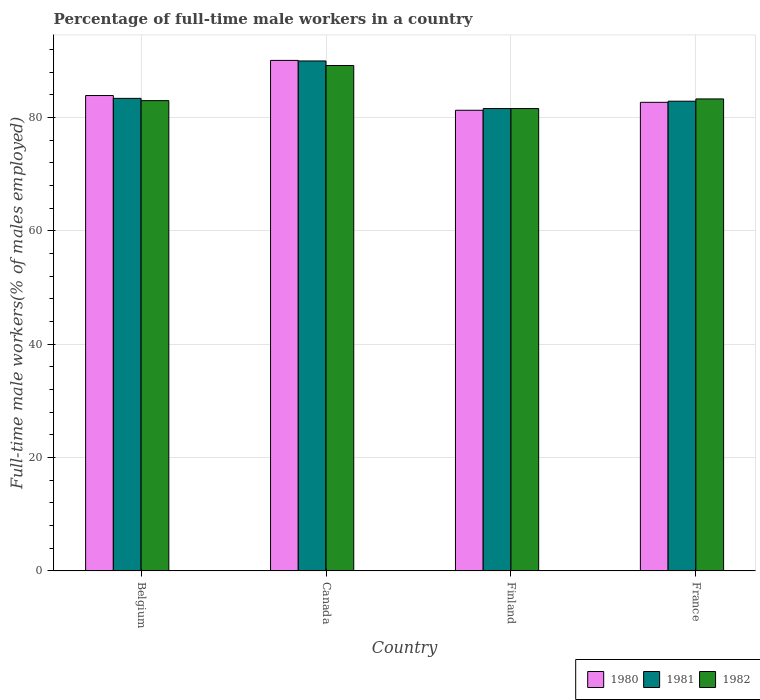How many different coloured bars are there?
Your answer should be very brief. 3. Are the number of bars per tick equal to the number of legend labels?
Make the answer very short. Yes. How many bars are there on the 4th tick from the left?
Give a very brief answer. 3. How many bars are there on the 1st tick from the right?
Your answer should be very brief. 3. What is the percentage of full-time male workers in 1980 in Belgium?
Your response must be concise. 83.9. Across all countries, what is the maximum percentage of full-time male workers in 1980?
Keep it short and to the point. 90.1. Across all countries, what is the minimum percentage of full-time male workers in 1982?
Your answer should be compact. 81.6. In which country was the percentage of full-time male workers in 1980 maximum?
Provide a short and direct response. Canada. In which country was the percentage of full-time male workers in 1981 minimum?
Your answer should be very brief. Finland. What is the total percentage of full-time male workers in 1982 in the graph?
Provide a short and direct response. 337.1. What is the difference between the percentage of full-time male workers in 1980 in Belgium and that in Finland?
Your answer should be very brief. 2.6. What is the difference between the percentage of full-time male workers in 1982 in Canada and the percentage of full-time male workers in 1981 in Finland?
Offer a very short reply. 7.6. What is the average percentage of full-time male workers in 1980 per country?
Keep it short and to the point. 84.5. What is the difference between the percentage of full-time male workers of/in 1982 and percentage of full-time male workers of/in 1980 in Finland?
Give a very brief answer. 0.3. What is the ratio of the percentage of full-time male workers in 1982 in Canada to that in Finland?
Provide a short and direct response. 1.09. Is the percentage of full-time male workers in 1980 in Belgium less than that in France?
Keep it short and to the point. No. What is the difference between the highest and the second highest percentage of full-time male workers in 1982?
Provide a short and direct response. 6.2. What is the difference between the highest and the lowest percentage of full-time male workers in 1982?
Provide a short and direct response. 7.6. In how many countries, is the percentage of full-time male workers in 1981 greater than the average percentage of full-time male workers in 1981 taken over all countries?
Provide a short and direct response. 1. What does the 2nd bar from the right in France represents?
Provide a short and direct response. 1981. Is it the case that in every country, the sum of the percentage of full-time male workers in 1981 and percentage of full-time male workers in 1982 is greater than the percentage of full-time male workers in 1980?
Your answer should be very brief. Yes. How many bars are there?
Provide a succinct answer. 12. Are all the bars in the graph horizontal?
Keep it short and to the point. No. How many countries are there in the graph?
Provide a succinct answer. 4. Are the values on the major ticks of Y-axis written in scientific E-notation?
Your answer should be very brief. No. Does the graph contain any zero values?
Your response must be concise. No. Does the graph contain grids?
Make the answer very short. Yes. Where does the legend appear in the graph?
Your answer should be very brief. Bottom right. How many legend labels are there?
Ensure brevity in your answer.  3. What is the title of the graph?
Keep it short and to the point. Percentage of full-time male workers in a country. What is the label or title of the Y-axis?
Your answer should be very brief. Full-time male workers(% of males employed). What is the Full-time male workers(% of males employed) of 1980 in Belgium?
Your response must be concise. 83.9. What is the Full-time male workers(% of males employed) in 1981 in Belgium?
Make the answer very short. 83.4. What is the Full-time male workers(% of males employed) of 1980 in Canada?
Offer a terse response. 90.1. What is the Full-time male workers(% of males employed) of 1981 in Canada?
Give a very brief answer. 90. What is the Full-time male workers(% of males employed) of 1982 in Canada?
Your answer should be compact. 89.2. What is the Full-time male workers(% of males employed) in 1980 in Finland?
Offer a very short reply. 81.3. What is the Full-time male workers(% of males employed) in 1981 in Finland?
Your response must be concise. 81.6. What is the Full-time male workers(% of males employed) of 1982 in Finland?
Provide a short and direct response. 81.6. What is the Full-time male workers(% of males employed) in 1980 in France?
Provide a short and direct response. 82.7. What is the Full-time male workers(% of males employed) in 1981 in France?
Your answer should be compact. 82.9. What is the Full-time male workers(% of males employed) in 1982 in France?
Offer a very short reply. 83.3. Across all countries, what is the maximum Full-time male workers(% of males employed) in 1980?
Ensure brevity in your answer.  90.1. Across all countries, what is the maximum Full-time male workers(% of males employed) of 1982?
Your answer should be very brief. 89.2. Across all countries, what is the minimum Full-time male workers(% of males employed) in 1980?
Offer a very short reply. 81.3. Across all countries, what is the minimum Full-time male workers(% of males employed) in 1981?
Ensure brevity in your answer.  81.6. Across all countries, what is the minimum Full-time male workers(% of males employed) in 1982?
Give a very brief answer. 81.6. What is the total Full-time male workers(% of males employed) of 1980 in the graph?
Give a very brief answer. 338. What is the total Full-time male workers(% of males employed) in 1981 in the graph?
Your answer should be compact. 337.9. What is the total Full-time male workers(% of males employed) of 1982 in the graph?
Make the answer very short. 337.1. What is the difference between the Full-time male workers(% of males employed) in 1980 in Belgium and that in Canada?
Provide a succinct answer. -6.2. What is the difference between the Full-time male workers(% of males employed) in 1981 in Belgium and that in Canada?
Provide a short and direct response. -6.6. What is the difference between the Full-time male workers(% of males employed) of 1982 in Belgium and that in Canada?
Offer a terse response. -6.2. What is the difference between the Full-time male workers(% of males employed) of 1980 in Belgium and that in Finland?
Give a very brief answer. 2.6. What is the difference between the Full-time male workers(% of males employed) of 1980 in Belgium and that in France?
Your answer should be compact. 1.2. What is the difference between the Full-time male workers(% of males employed) of 1980 in Canada and that in Finland?
Make the answer very short. 8.8. What is the difference between the Full-time male workers(% of males employed) of 1982 in Canada and that in Finland?
Give a very brief answer. 7.6. What is the difference between the Full-time male workers(% of males employed) in 1980 in Canada and that in France?
Your response must be concise. 7.4. What is the difference between the Full-time male workers(% of males employed) in 1981 in Canada and that in France?
Make the answer very short. 7.1. What is the difference between the Full-time male workers(% of males employed) of 1982 in Canada and that in France?
Give a very brief answer. 5.9. What is the difference between the Full-time male workers(% of males employed) in 1982 in Finland and that in France?
Ensure brevity in your answer.  -1.7. What is the difference between the Full-time male workers(% of males employed) in 1980 in Belgium and the Full-time male workers(% of males employed) in 1981 in Canada?
Your answer should be very brief. -6.1. What is the difference between the Full-time male workers(% of males employed) in 1980 in Belgium and the Full-time male workers(% of males employed) in 1982 in Canada?
Offer a terse response. -5.3. What is the difference between the Full-time male workers(% of males employed) of 1981 in Belgium and the Full-time male workers(% of males employed) of 1982 in Finland?
Provide a succinct answer. 1.8. What is the difference between the Full-time male workers(% of males employed) in 1980 in Belgium and the Full-time male workers(% of males employed) in 1981 in France?
Ensure brevity in your answer.  1. What is the difference between the Full-time male workers(% of males employed) in 1980 in Belgium and the Full-time male workers(% of males employed) in 1982 in France?
Your answer should be compact. 0.6. What is the difference between the Full-time male workers(% of males employed) in 1980 in Canada and the Full-time male workers(% of males employed) in 1981 in Finland?
Ensure brevity in your answer.  8.5. What is the difference between the Full-time male workers(% of males employed) in 1980 in Canada and the Full-time male workers(% of males employed) in 1982 in Finland?
Your answer should be very brief. 8.5. What is the difference between the Full-time male workers(% of males employed) in 1981 in Canada and the Full-time male workers(% of males employed) in 1982 in Finland?
Offer a terse response. 8.4. What is the difference between the Full-time male workers(% of males employed) in 1980 in Canada and the Full-time male workers(% of males employed) in 1981 in France?
Ensure brevity in your answer.  7.2. What is the difference between the Full-time male workers(% of males employed) in 1980 in Canada and the Full-time male workers(% of males employed) in 1982 in France?
Make the answer very short. 6.8. What is the difference between the Full-time male workers(% of males employed) in 1981 in Canada and the Full-time male workers(% of males employed) in 1982 in France?
Offer a very short reply. 6.7. What is the difference between the Full-time male workers(% of males employed) in 1980 in Finland and the Full-time male workers(% of males employed) in 1981 in France?
Make the answer very short. -1.6. What is the difference between the Full-time male workers(% of males employed) of 1981 in Finland and the Full-time male workers(% of males employed) of 1982 in France?
Provide a short and direct response. -1.7. What is the average Full-time male workers(% of males employed) in 1980 per country?
Offer a very short reply. 84.5. What is the average Full-time male workers(% of males employed) of 1981 per country?
Keep it short and to the point. 84.47. What is the average Full-time male workers(% of males employed) of 1982 per country?
Provide a short and direct response. 84.28. What is the difference between the Full-time male workers(% of males employed) of 1980 and Full-time male workers(% of males employed) of 1981 in Belgium?
Your answer should be compact. 0.5. What is the difference between the Full-time male workers(% of males employed) of 1980 and Full-time male workers(% of males employed) of 1982 in Belgium?
Provide a short and direct response. 0.9. What is the difference between the Full-time male workers(% of males employed) in 1980 and Full-time male workers(% of males employed) in 1982 in Canada?
Offer a very short reply. 0.9. What is the difference between the Full-time male workers(% of males employed) of 1981 and Full-time male workers(% of males employed) of 1982 in Canada?
Ensure brevity in your answer.  0.8. What is the difference between the Full-time male workers(% of males employed) of 1980 and Full-time male workers(% of males employed) of 1982 in Finland?
Offer a terse response. -0.3. What is the difference between the Full-time male workers(% of males employed) in 1980 and Full-time male workers(% of males employed) in 1981 in France?
Make the answer very short. -0.2. What is the difference between the Full-time male workers(% of males employed) of 1980 and Full-time male workers(% of males employed) of 1982 in France?
Make the answer very short. -0.6. What is the ratio of the Full-time male workers(% of males employed) of 1980 in Belgium to that in Canada?
Provide a short and direct response. 0.93. What is the ratio of the Full-time male workers(% of males employed) in 1981 in Belgium to that in Canada?
Keep it short and to the point. 0.93. What is the ratio of the Full-time male workers(% of males employed) in 1982 in Belgium to that in Canada?
Your answer should be compact. 0.93. What is the ratio of the Full-time male workers(% of males employed) of 1980 in Belgium to that in Finland?
Give a very brief answer. 1.03. What is the ratio of the Full-time male workers(% of males employed) of 1981 in Belgium to that in Finland?
Your answer should be compact. 1.02. What is the ratio of the Full-time male workers(% of males employed) in 1982 in Belgium to that in Finland?
Offer a very short reply. 1.02. What is the ratio of the Full-time male workers(% of males employed) in 1980 in Belgium to that in France?
Offer a very short reply. 1.01. What is the ratio of the Full-time male workers(% of males employed) in 1981 in Belgium to that in France?
Your answer should be very brief. 1.01. What is the ratio of the Full-time male workers(% of males employed) of 1980 in Canada to that in Finland?
Your response must be concise. 1.11. What is the ratio of the Full-time male workers(% of males employed) of 1981 in Canada to that in Finland?
Provide a short and direct response. 1.1. What is the ratio of the Full-time male workers(% of males employed) in 1982 in Canada to that in Finland?
Provide a succinct answer. 1.09. What is the ratio of the Full-time male workers(% of males employed) in 1980 in Canada to that in France?
Give a very brief answer. 1.09. What is the ratio of the Full-time male workers(% of males employed) in 1981 in Canada to that in France?
Your response must be concise. 1.09. What is the ratio of the Full-time male workers(% of males employed) of 1982 in Canada to that in France?
Your response must be concise. 1.07. What is the ratio of the Full-time male workers(% of males employed) of 1980 in Finland to that in France?
Your answer should be very brief. 0.98. What is the ratio of the Full-time male workers(% of males employed) in 1981 in Finland to that in France?
Make the answer very short. 0.98. What is the ratio of the Full-time male workers(% of males employed) of 1982 in Finland to that in France?
Offer a very short reply. 0.98. What is the difference between the highest and the lowest Full-time male workers(% of males employed) of 1980?
Provide a succinct answer. 8.8. What is the difference between the highest and the lowest Full-time male workers(% of males employed) of 1982?
Make the answer very short. 7.6. 